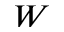<formula> <loc_0><loc_0><loc_500><loc_500>W</formula> 